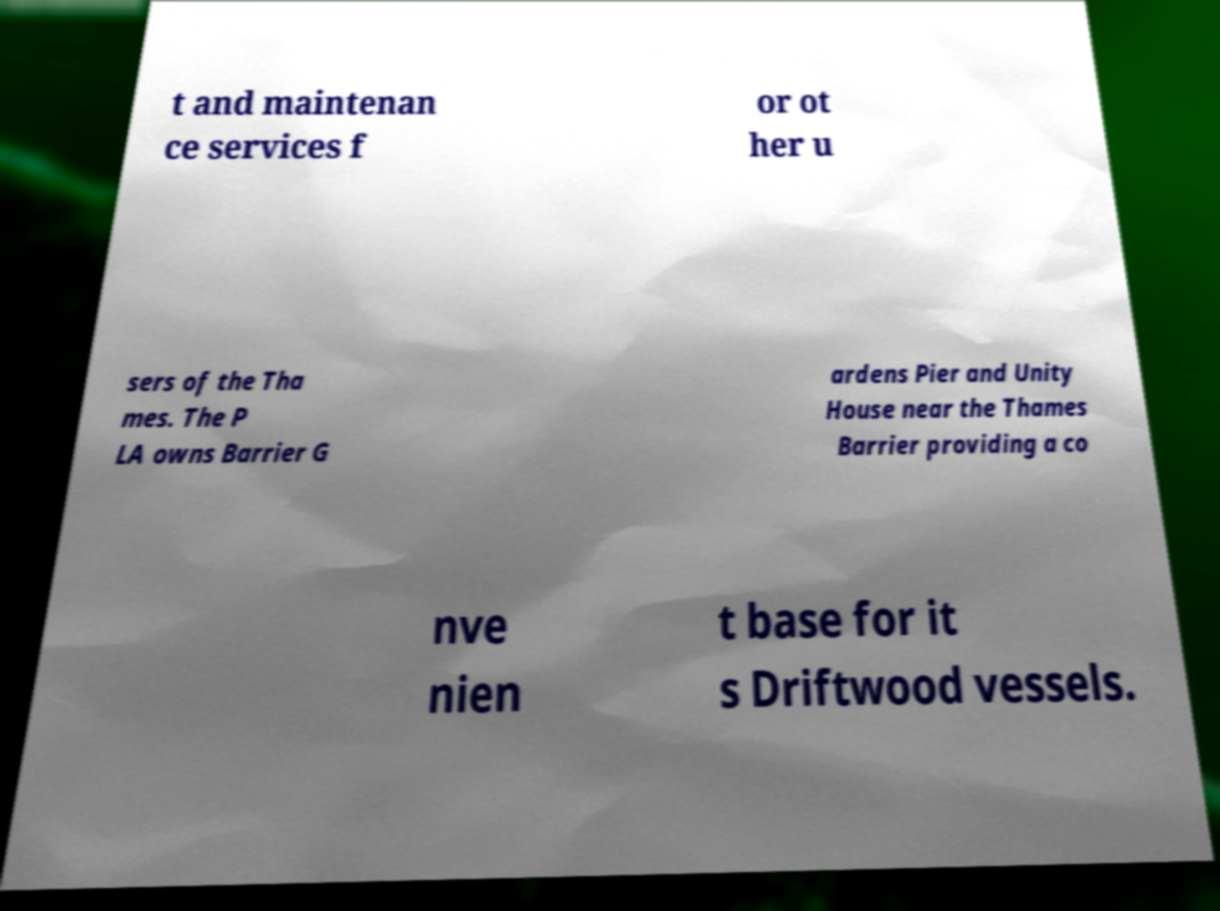I need the written content from this picture converted into text. Can you do that? t and maintenan ce services f or ot her u sers of the Tha mes. The P LA owns Barrier G ardens Pier and Unity House near the Thames Barrier providing a co nve nien t base for it s Driftwood vessels. 